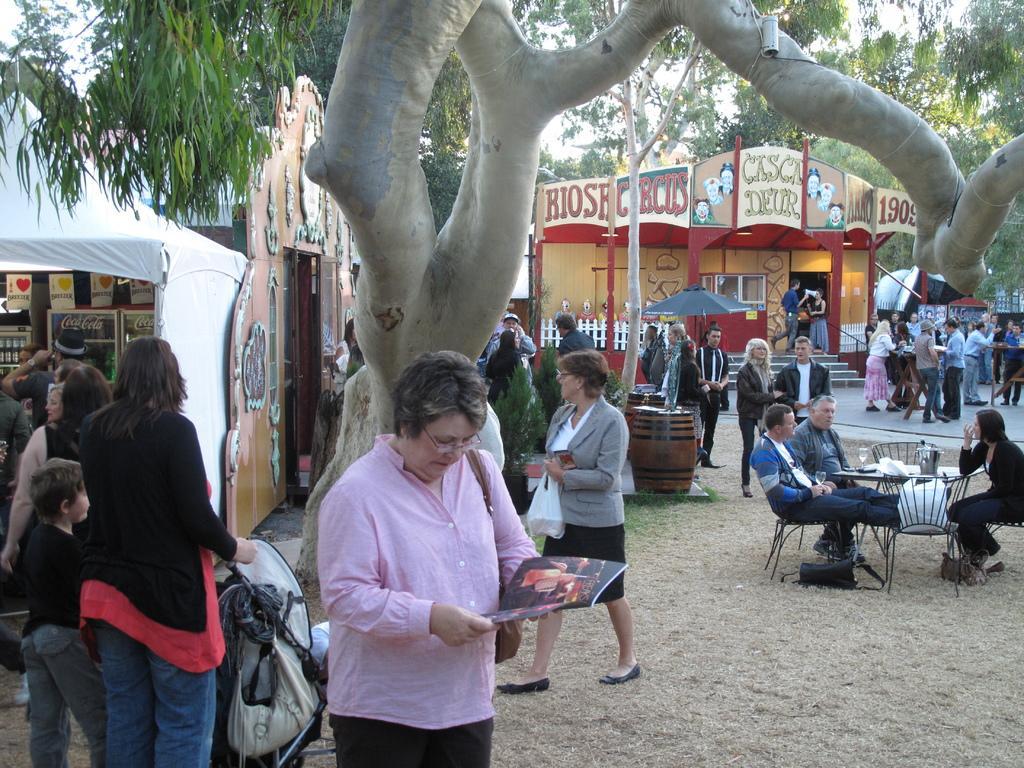Please provide a concise description of this image. There is a woman standing in the center and she is looking at a magazine. There are a few people on the left side. Here we can see a three people who are sitting on a chair and having a conversation. In the background we can observe a few people who are standing and doing something. 